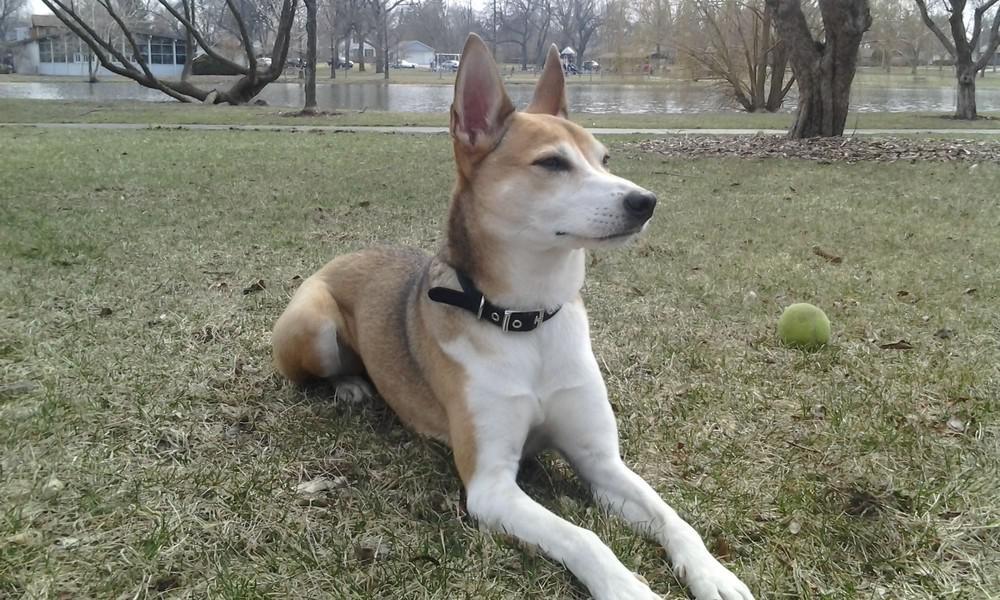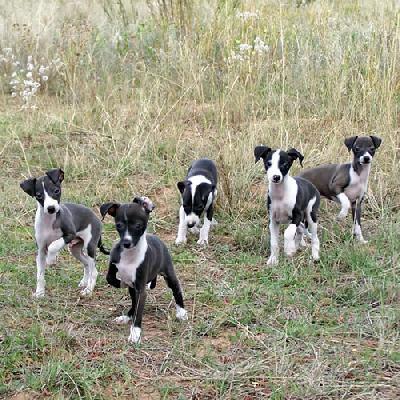The first image is the image on the left, the second image is the image on the right. Examine the images to the left and right. Is the description "One of the paired images shows multiple black and white dogs." accurate? Answer yes or no. Yes. 